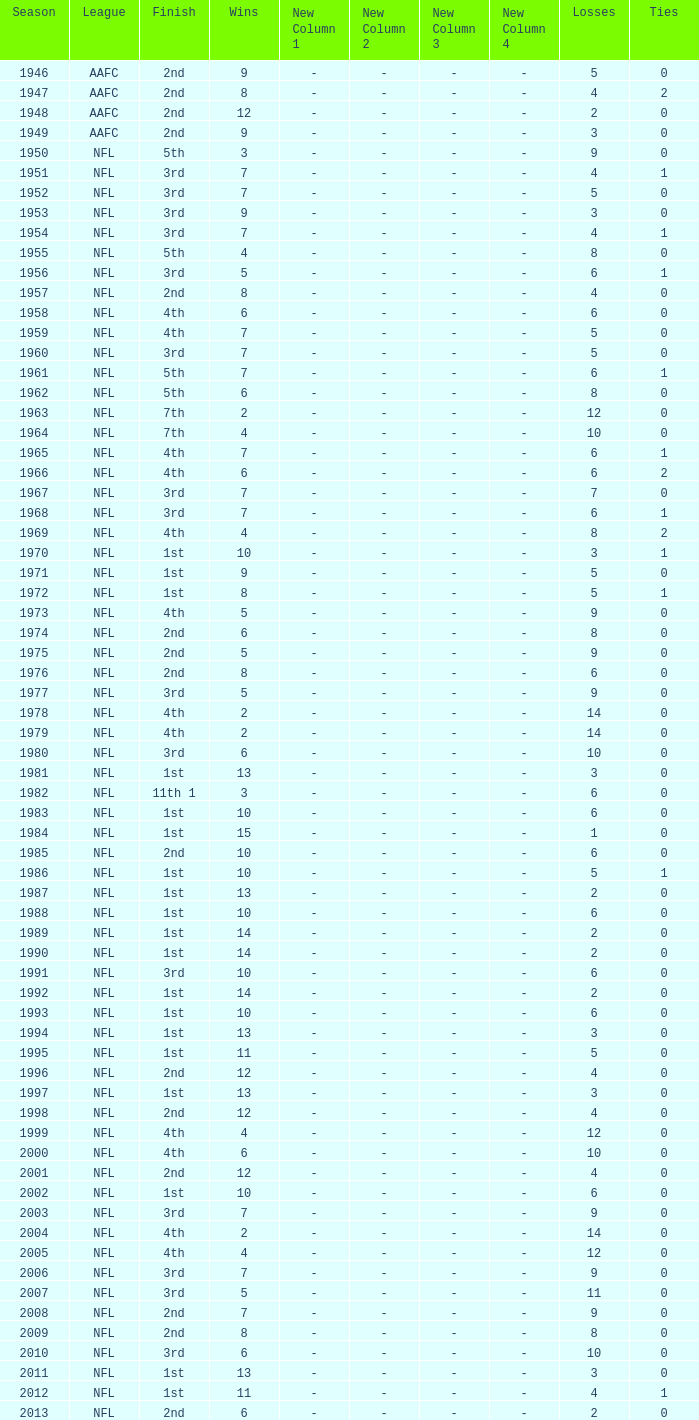Give me the full table as a dictionary. {'header': ['Season', 'League', 'Finish', 'Wins', 'New Column 1', 'New Column 2', 'New Column 3', 'New Column 4', 'Losses', 'Ties'], 'rows': [['1946', 'AAFC', '2nd', '9', '-', '-', '-', '-', '5', '0'], ['1947', 'AAFC', '2nd', '8', '-', '-', '-', '-', '4', '2'], ['1948', 'AAFC', '2nd', '12', '-', '-', '-', '-', '2', '0'], ['1949', 'AAFC', '2nd', '9', '-', '-', '-', '-', '3', '0'], ['1950', 'NFL', '5th', '3', '-', '-', '-', '-', '9', '0'], ['1951', 'NFL', '3rd', '7', '-', '-', '-', '-', '4', '1'], ['1952', 'NFL', '3rd', '7', '-', '-', '-', '-', '5', '0'], ['1953', 'NFL', '3rd', '9', '-', '-', '-', '-', '3', '0'], ['1954', 'NFL', '3rd', '7', '-', '-', '-', '-', '4', '1'], ['1955', 'NFL', '5th', '4', '-', '-', '-', '-', '8', '0'], ['1956', 'NFL', '3rd', '5', '-', '-', '-', '-', '6', '1'], ['1957', 'NFL', '2nd', '8', '-', '-', '-', '-', '4', '0'], ['1958', 'NFL', '4th', '6', '-', '-', '-', '-', '6', '0'], ['1959', 'NFL', '4th', '7', '-', '-', '-', '-', '5', '0'], ['1960', 'NFL', '3rd', '7', '-', '-', '-', '-', '5', '0'], ['1961', 'NFL', '5th', '7', '-', '-', '-', '-', '6', '1'], ['1962', 'NFL', '5th', '6', '-', '-', '-', '-', '8', '0'], ['1963', 'NFL', '7th', '2', '-', '-', '-', '-', '12', '0'], ['1964', 'NFL', '7th', '4', '-', '-', '-', '-', '10', '0'], ['1965', 'NFL', '4th', '7', '-', '-', '-', '-', '6', '1'], ['1966', 'NFL', '4th', '6', '-', '-', '-', '-', '6', '2'], ['1967', 'NFL', '3rd', '7', '-', '-', '-', '-', '7', '0'], ['1968', 'NFL', '3rd', '7', '-', '-', '-', '-', '6', '1'], ['1969', 'NFL', '4th', '4', '-', '-', '-', '-', '8', '2'], ['1970', 'NFL', '1st', '10', '-', '-', '-', '-', '3', '1'], ['1971', 'NFL', '1st', '9', '-', '-', '-', '-', '5', '0'], ['1972', 'NFL', '1st', '8', '-', '-', '-', '-', '5', '1'], ['1973', 'NFL', '4th', '5', '-', '-', '-', '-', '9', '0'], ['1974', 'NFL', '2nd', '6', '-', '-', '-', '-', '8', '0'], ['1975', 'NFL', '2nd', '5', '-', '-', '-', '-', '9', '0'], ['1976', 'NFL', '2nd', '8', '-', '-', '-', '-', '6', '0'], ['1977', 'NFL', '3rd', '5', '-', '-', '-', '-', '9', '0'], ['1978', 'NFL', '4th', '2', '-', '-', '-', '-', '14', '0'], ['1979', 'NFL', '4th', '2', '-', '-', '-', '-', '14', '0'], ['1980', 'NFL', '3rd', '6', '-', '-', '-', '-', '10', '0'], ['1981', 'NFL', '1st', '13', '-', '-', '-', '-', '3', '0'], ['1982', 'NFL', '11th 1', '3', '-', '-', '-', '-', '6', '0'], ['1983', 'NFL', '1st', '10', '-', '-', '-', '-', '6', '0'], ['1984', 'NFL', '1st', '15', '-', '-', '-', '-', '1', '0'], ['1985', 'NFL', '2nd', '10', '-', '-', '-', '-', '6', '0'], ['1986', 'NFL', '1st', '10', '-', '-', '-', '-', '5', '1'], ['1987', 'NFL', '1st', '13', '-', '-', '-', '-', '2', '0'], ['1988', 'NFL', '1st', '10', '-', '-', '-', '-', '6', '0'], ['1989', 'NFL', '1st', '14', '-', '-', '-', '-', '2', '0'], ['1990', 'NFL', '1st', '14', '-', '-', '-', '-', '2', '0'], ['1991', 'NFL', '3rd', '10', '-', '-', '-', '-', '6', '0'], ['1992', 'NFL', '1st', '14', '-', '-', '-', '-', '2', '0'], ['1993', 'NFL', '1st', '10', '-', '-', '-', '-', '6', '0'], ['1994', 'NFL', '1st', '13', '-', '-', '-', '-', '3', '0'], ['1995', 'NFL', '1st', '11', '-', '-', '-', '-', '5', '0'], ['1996', 'NFL', '2nd', '12', '-', '-', '-', '-', '4', '0'], ['1997', 'NFL', '1st', '13', '-', '-', '-', '-', '3', '0'], ['1998', 'NFL', '2nd', '12', '-', '-', '-', '-', '4', '0'], ['1999', 'NFL', '4th', '4', '-', '-', '-', '-', '12', '0'], ['2000', 'NFL', '4th', '6', '-', '-', '-', '-', '10', '0'], ['2001', 'NFL', '2nd', '12', '-', '-', '-', '-', '4', '0'], ['2002', 'NFL', '1st', '10', '-', '-', '-', '-', '6', '0'], ['2003', 'NFL', '3rd', '7', '-', '-', '-', '-', '9', '0'], ['2004', 'NFL', '4th', '2', '-', '-', '-', '-', '14', '0'], ['2005', 'NFL', '4th', '4', '-', '-', '-', '-', '12', '0'], ['2006', 'NFL', '3rd', '7', '-', '-', '-', '-', '9', '0'], ['2007', 'NFL', '3rd', '5', '-', '-', '-', '-', '11', '0'], ['2008', 'NFL', '2nd', '7', '-', '-', '-', '-', '9', '0'], ['2009', 'NFL', '2nd', '8', '-', '-', '-', '-', '8', '0'], ['2010', 'NFL', '3rd', '6', '-', '-', '-', '-', '10', '0'], ['2011', 'NFL', '1st', '13', '-', '-', '-', '-', '3', '0'], ['2012', 'NFL', '1st', '11', '-', '-', '-', '-', '4', '1'], ['2013', 'NFL', '2nd', '6', '-', '-', '-', '-', '2', '0']]} What were the loss counts for nfl teams with under 13 wins during the 2011 season? None. 